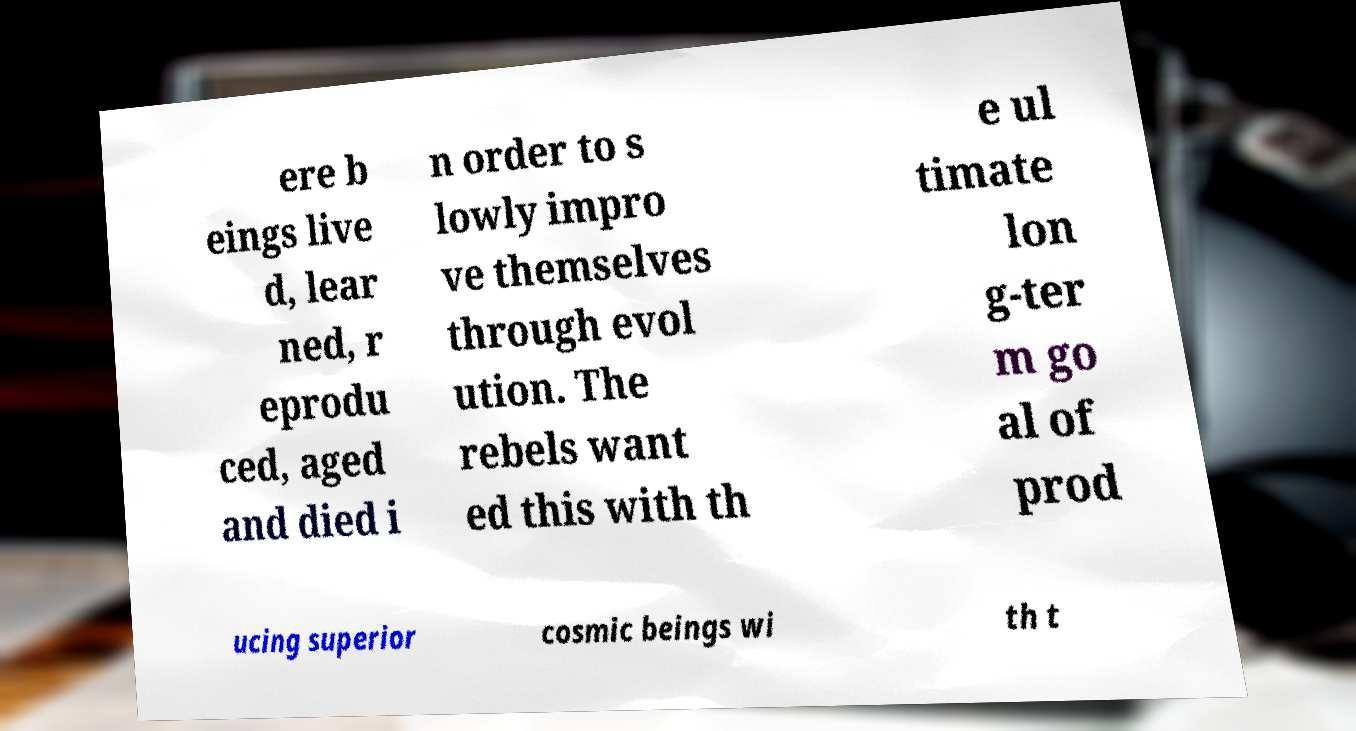Can you read and provide the text displayed in the image?This photo seems to have some interesting text. Can you extract and type it out for me? ere b eings live d, lear ned, r eprodu ced, aged and died i n order to s lowly impro ve themselves through evol ution. The rebels want ed this with th e ul timate lon g-ter m go al of prod ucing superior cosmic beings wi th t 